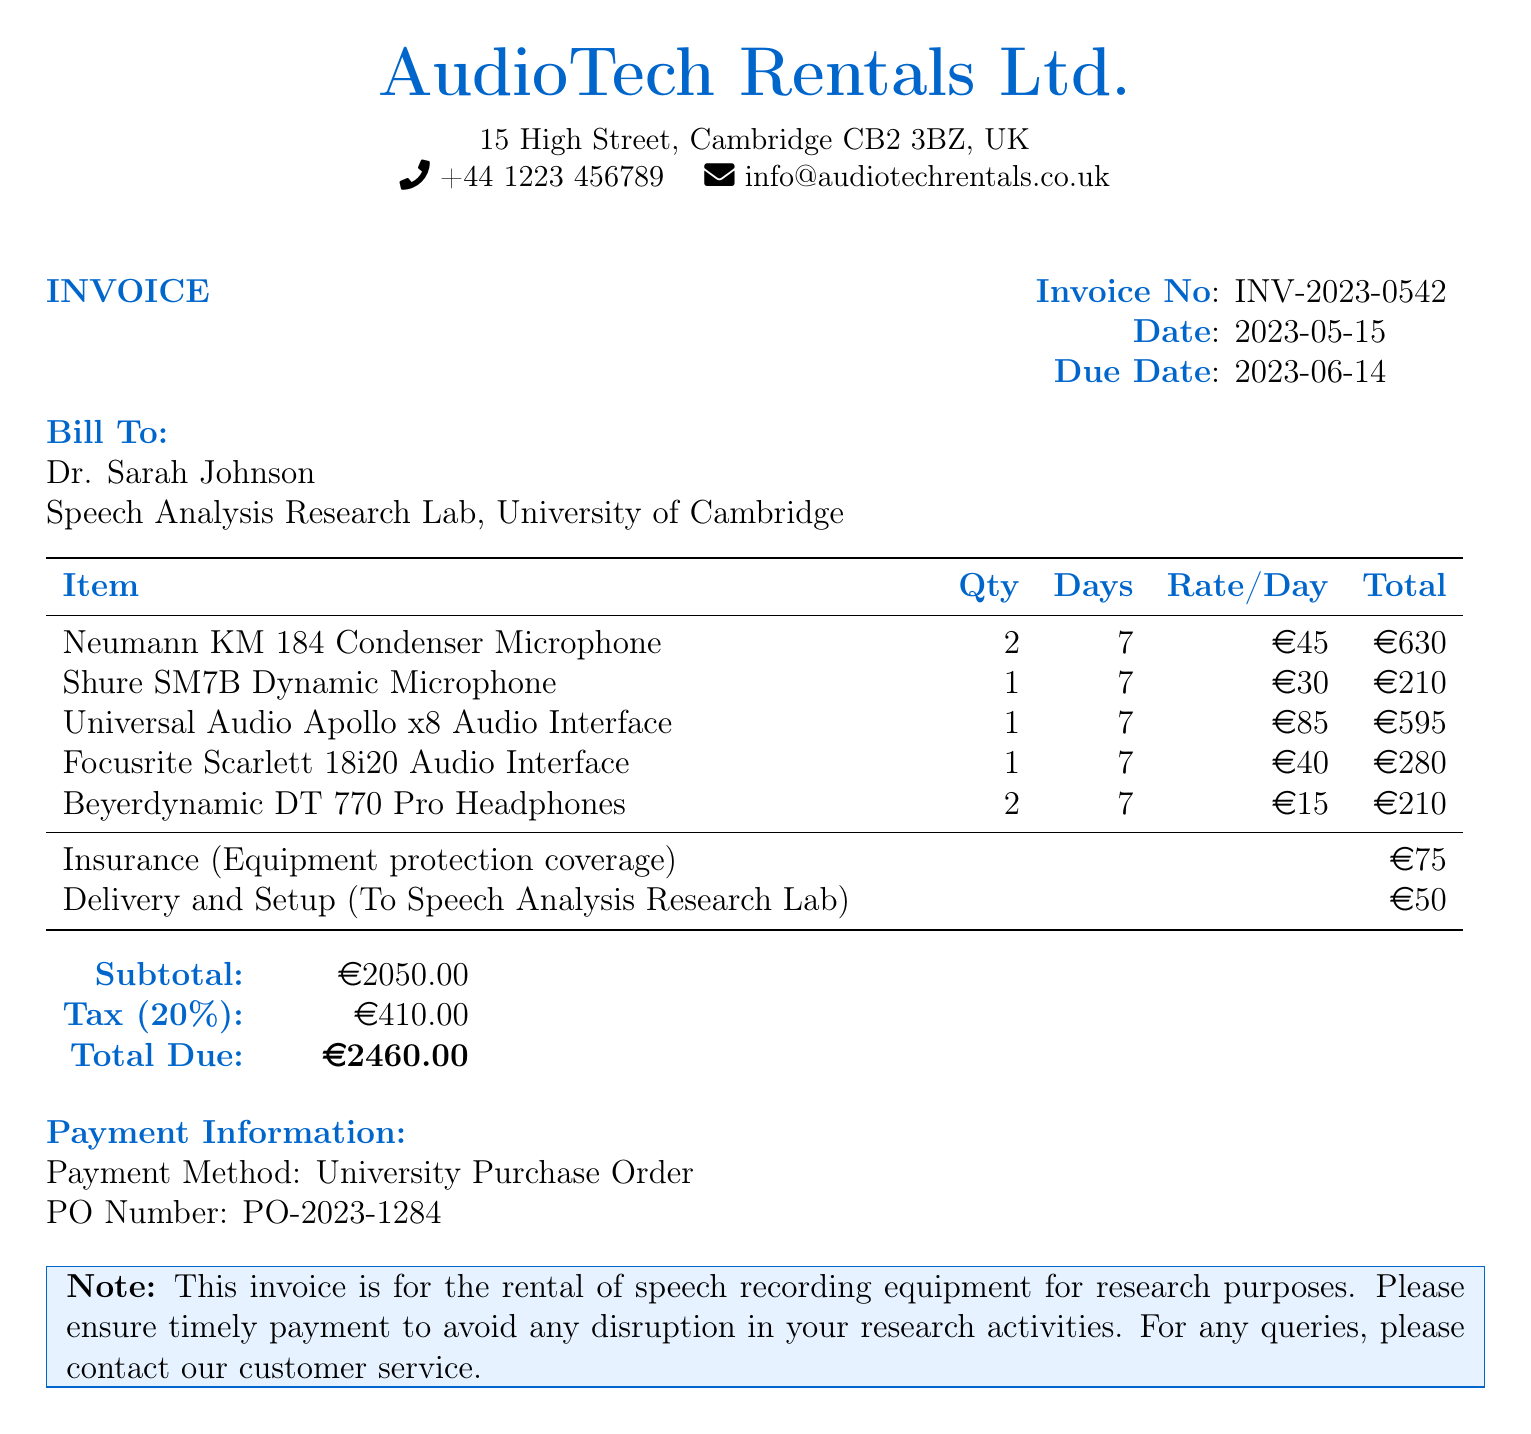What is the invoice number? The invoice number is specified in the document and is used to track the transaction.
Answer: INV-2023-0542 Who is the bill addressed to? The bill includes a "Bill To" section that specifies the recipient of the invoice.
Answer: Dr. Sarah Johnson What is the total due amount? The total due is calculated based on the subtotal and tax, presented in the "Total Due" section.
Answer: €2460.00 How many days was the equipment rented? The duration of the rental is indicated under the "Days" column for each item.
Answer: 7 What is the tax percentage applied? The document specifies a tax rate that is applied to the subtotal, which is commonly noted on invoices.
Answer: 20% What type of payment method is mentioned? The payment method is specified for the transaction, indicating how the recipient should handle payment.
Answer: University Purchase Order What is the subtotal amount before tax? The subtotal amount is noted before the tax calculation in the document.
Answer: €2050.00 What is included in the delivery and setup charge? The document outlines services provided, particularly expenses related to setup and delivery.
Answer: €50 How many microphones were rented in total? The total quantity of microphones rented can be found in the "Qty" column of the document.
Answer: 3 